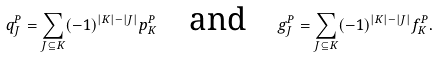Convert formula to latex. <formula><loc_0><loc_0><loc_500><loc_500>q _ { J } ^ { P } = \sum _ { J \subseteq K } ( - 1 ) ^ { | K | - | J | } p _ { K } ^ { P } \quad \text {and} \quad g _ { J } ^ { P } = \sum _ { J \subseteq K } ( - 1 ) ^ { | K | - | J | } f _ { K } ^ { P } .</formula> 